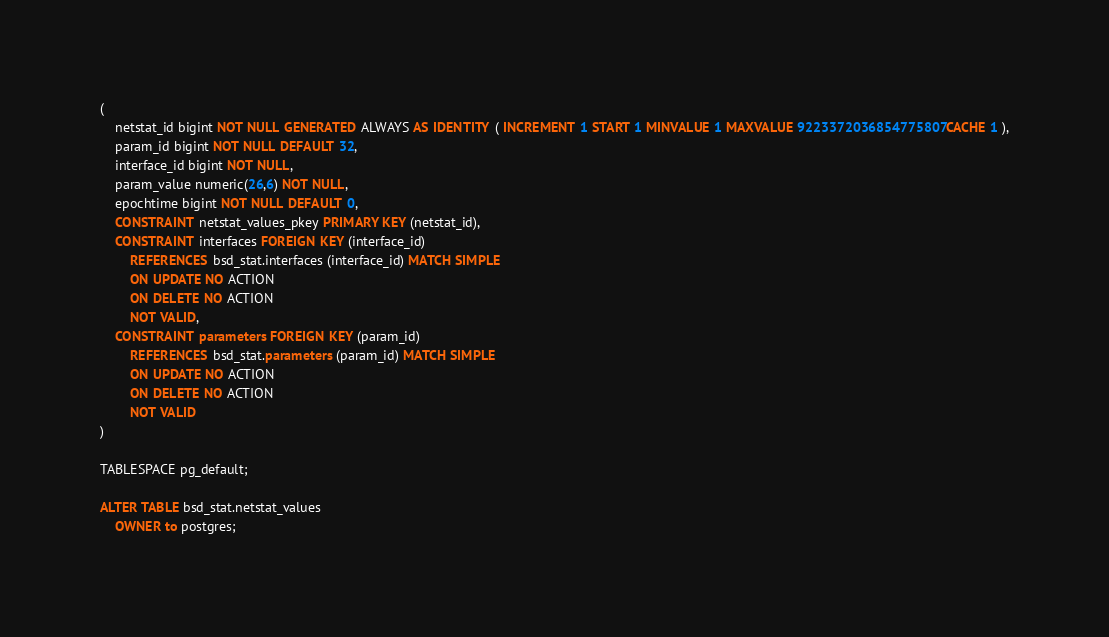Convert code to text. <code><loc_0><loc_0><loc_500><loc_500><_SQL_>(
    netstat_id bigint NOT NULL GENERATED ALWAYS AS IDENTITY ( INCREMENT 1 START 1 MINVALUE 1 MAXVALUE 9223372036854775807 CACHE 1 ),
    param_id bigint NOT NULL DEFAULT 32,
    interface_id bigint NOT NULL,
    param_value numeric(26,6) NOT NULL,
    epochtime bigint NOT NULL DEFAULT 0,
    CONSTRAINT netstat_values_pkey PRIMARY KEY (netstat_id),
    CONSTRAINT interfaces FOREIGN KEY (interface_id)
        REFERENCES bsd_stat.interfaces (interface_id) MATCH SIMPLE
        ON UPDATE NO ACTION
        ON DELETE NO ACTION
        NOT VALID,
    CONSTRAINT parameters FOREIGN KEY (param_id)
        REFERENCES bsd_stat.parameters (param_id) MATCH SIMPLE
        ON UPDATE NO ACTION
        ON DELETE NO ACTION
        NOT VALID
)

TABLESPACE pg_default;

ALTER TABLE bsd_stat.netstat_values
    OWNER to postgres;</code> 